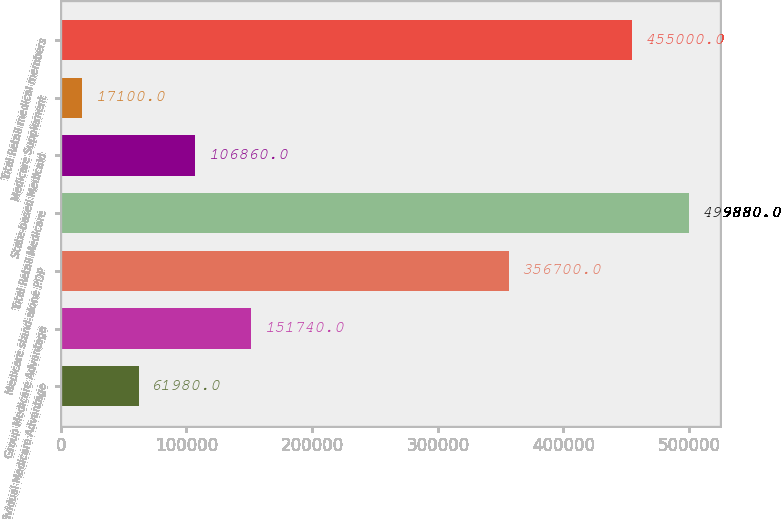Convert chart to OTSL. <chart><loc_0><loc_0><loc_500><loc_500><bar_chart><fcel>Individual Medicare Advantage<fcel>Group Medicare Advantage<fcel>Medicare stand-alone PDP<fcel>Total Retail Medicare<fcel>State-based Medicaid<fcel>Medicare Supplement<fcel>Total Retail medical members<nl><fcel>61980<fcel>151740<fcel>356700<fcel>499880<fcel>106860<fcel>17100<fcel>455000<nl></chart> 